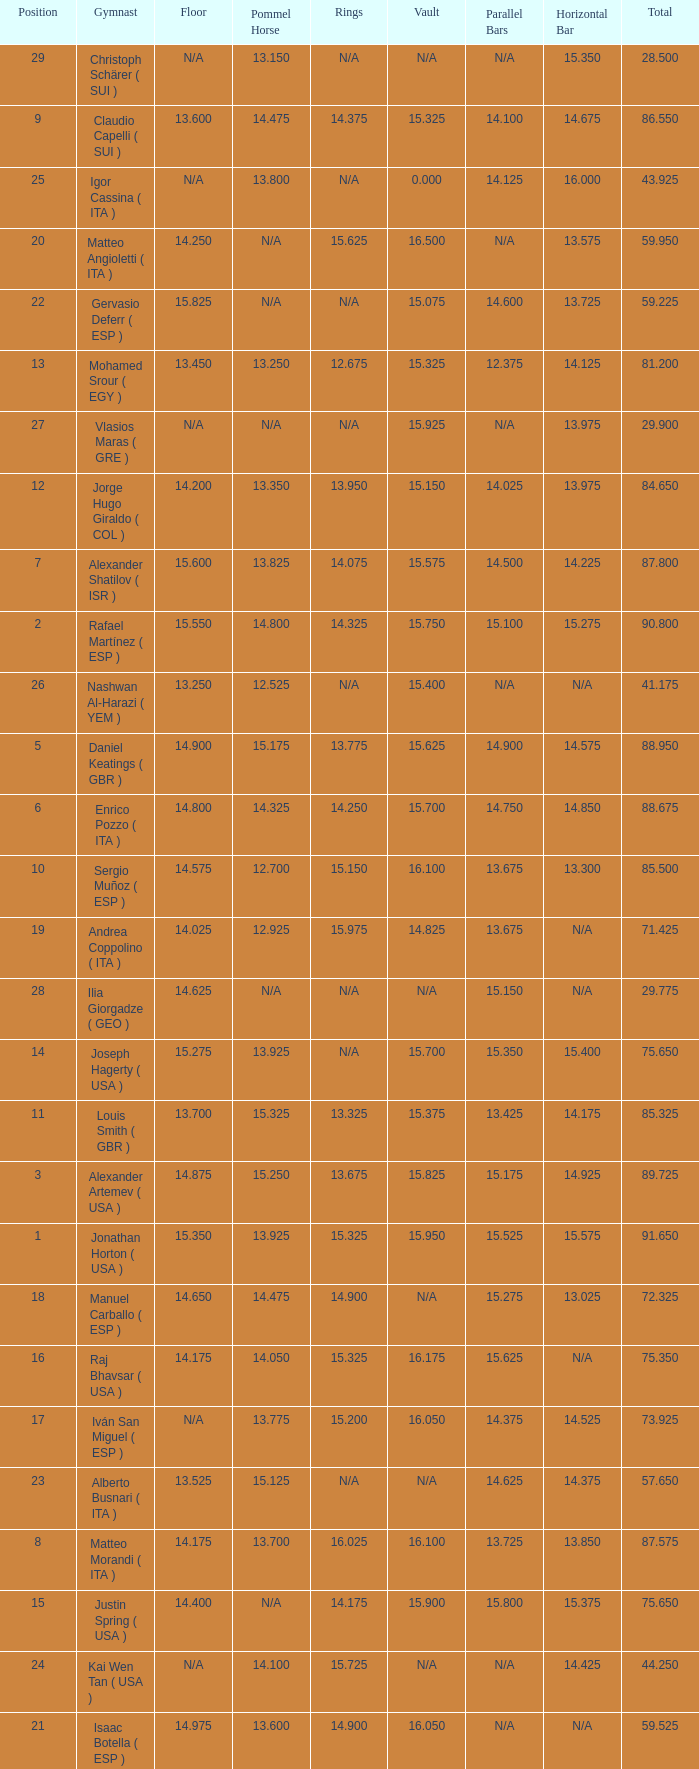If the parallel bars is 16.150, who is the gymnast? Anton Fokin ( UZB ). 